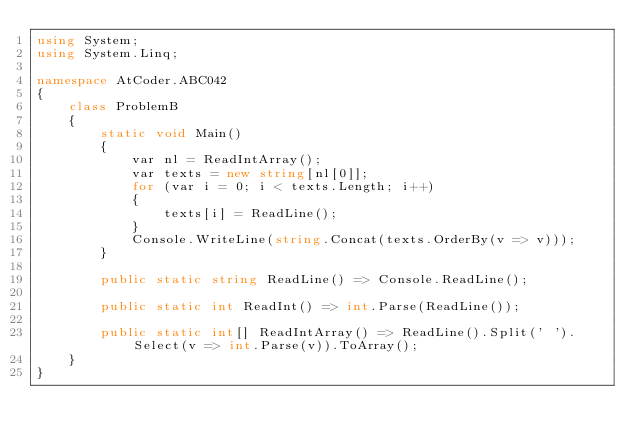Convert code to text. <code><loc_0><loc_0><loc_500><loc_500><_C#_>using System;
using System.Linq;

namespace AtCoder.ABC042
{
    class ProblemB
    {
        static void Main()
        {
            var nl = ReadIntArray();
            var texts = new string[nl[0]];
            for (var i = 0; i < texts.Length; i++)
            {
                texts[i] = ReadLine();
            }
            Console.WriteLine(string.Concat(texts.OrderBy(v => v)));
        }

        public static string ReadLine() => Console.ReadLine();

        public static int ReadInt() => int.Parse(ReadLine());

        public static int[] ReadIntArray() => ReadLine().Split(' ').Select(v => int.Parse(v)).ToArray();
    }
}
</code> 